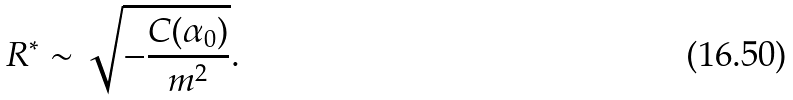<formula> <loc_0><loc_0><loc_500><loc_500>R ^ { \ast } \sim \sqrt { - \frac { C ( \alpha _ { 0 } ) } { m ^ { 2 } } } .</formula> 